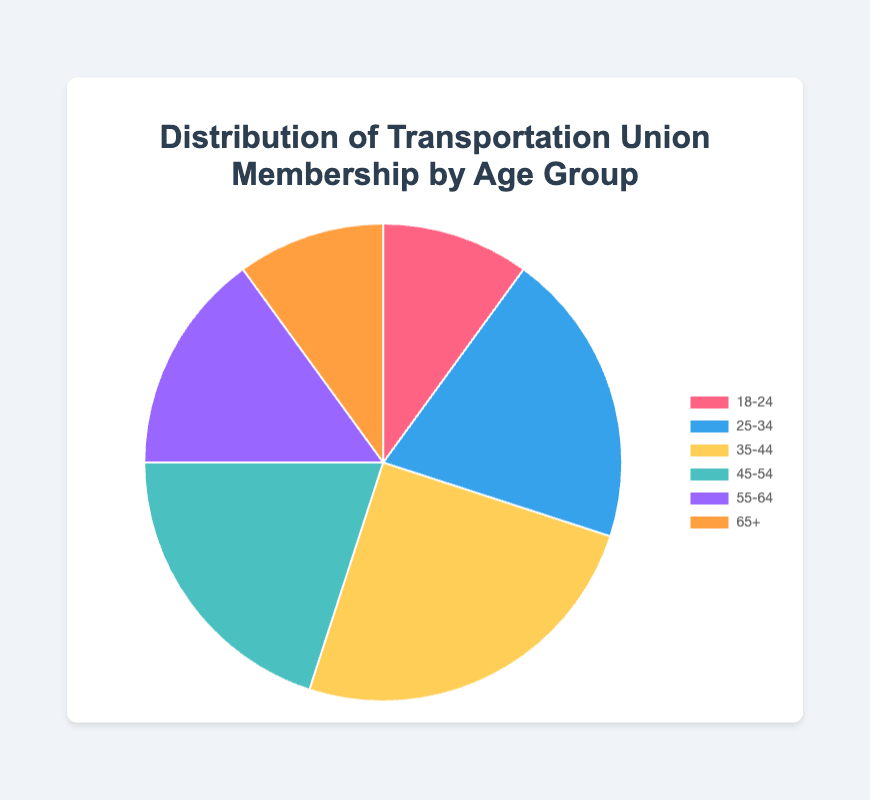Which age group has the highest percentage of transportation union membership? From the pie chart, the largest slice corresponds to the age group 35-44, indicating this group has the highest percentage.
Answer: 35-44 Which two age groups have equal union membership percentages? Observing the pie chart, the slices for the 18-24 and 65+ age groups are equal in size, both representing the same percentage.
Answer: 18-24 and 65+ What is the total percentage of union members aged 18-34? Summing the percentages of age groups 18-24 (10%) and 25-34 (20%), the total is 10% + 20% = 30%.
Answer: 30% How much more is the percentage of union members aged 35-44 compared to those aged 55-64? Subtracting the percentage of the 55-64 age group (15%) from the 35-44 age group (25%), the difference is 25% - 15% = 10%.
Answer: 10% Is the percentage of union members aged 45-54 greater than those aged 18-24? Comparing the slices, the 45-54 age group (20%) is larger than the 18-24 age group (10%).
Answer: Yes What is the combined percentage of union members aged 45 and above? Summing the percentages for age groups 45-54 (20%), 55-64 (15%), and 65+ (10%), the total is 20% + 15% + 10% = 45%.
Answer: 45% Which color represents the age group with the second-highest percentage of union membership? Noticing the colors, the second-largest slice corresponds to the 25-34 age group, which is colored blue.
Answer: Blue What is the difference in percentage points between the age groups 25-34 and 35-44? Subtracting the percentage of the 25-34 age group (20%) from the 35-44 age group (25%), the difference is 25% - 20% = 5%.
Answer: 5% Does any age group have exactly 15% union membership? Observing the slices, the only group with 15% is the 55-64 age group.
Answer: Yes Which age groups together make up 50% of the union membership? Adding the percentages of the 35-44 and 25-34 age groups, 25% + 20% = 45%, then adding the 10% of the 18-24 age group reaches 55% which exceeds 50%, but 35-44 and 45-54 together make up exactly 45%. Thus, summing up age groups 35-44 and 45-54 gives only 45%. We look further to see that 35-44 + 25-34 results in 50%.
Answer: 35-44 and 25-34 